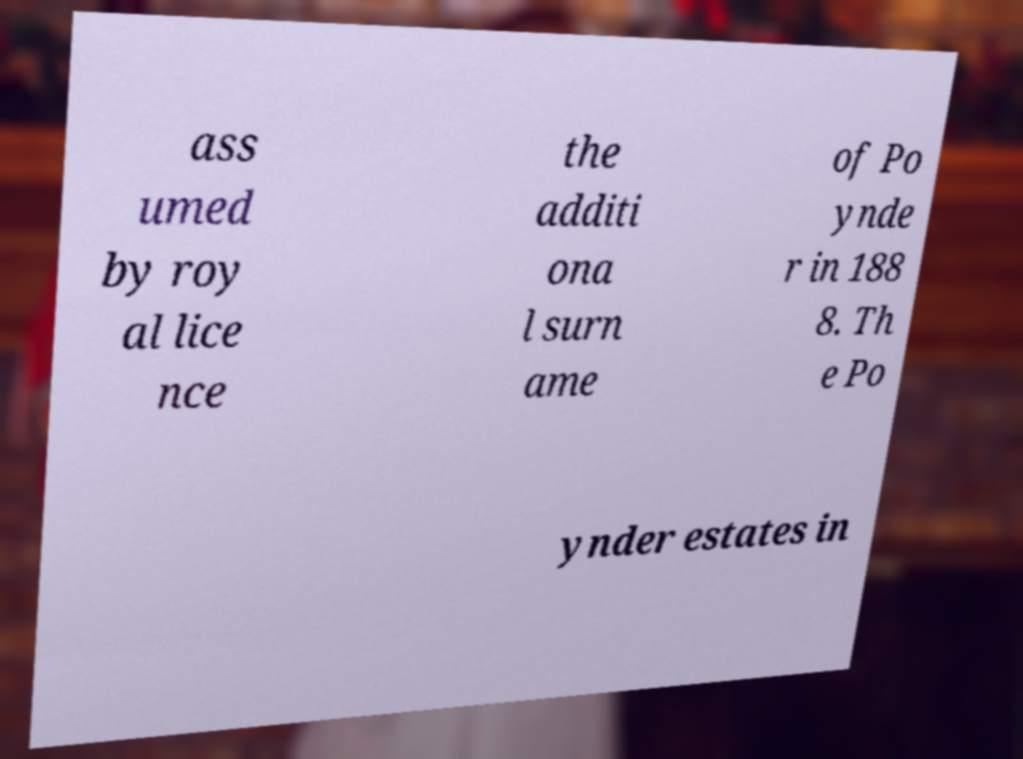Could you assist in decoding the text presented in this image and type it out clearly? ass umed by roy al lice nce the additi ona l surn ame of Po ynde r in 188 8. Th e Po ynder estates in 